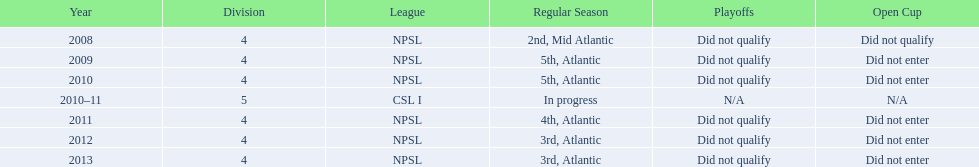What are the titles of the leagues? NPSL, CSL I. In addition to npsl, in which league did the ny soccer team participate? CSL I. 